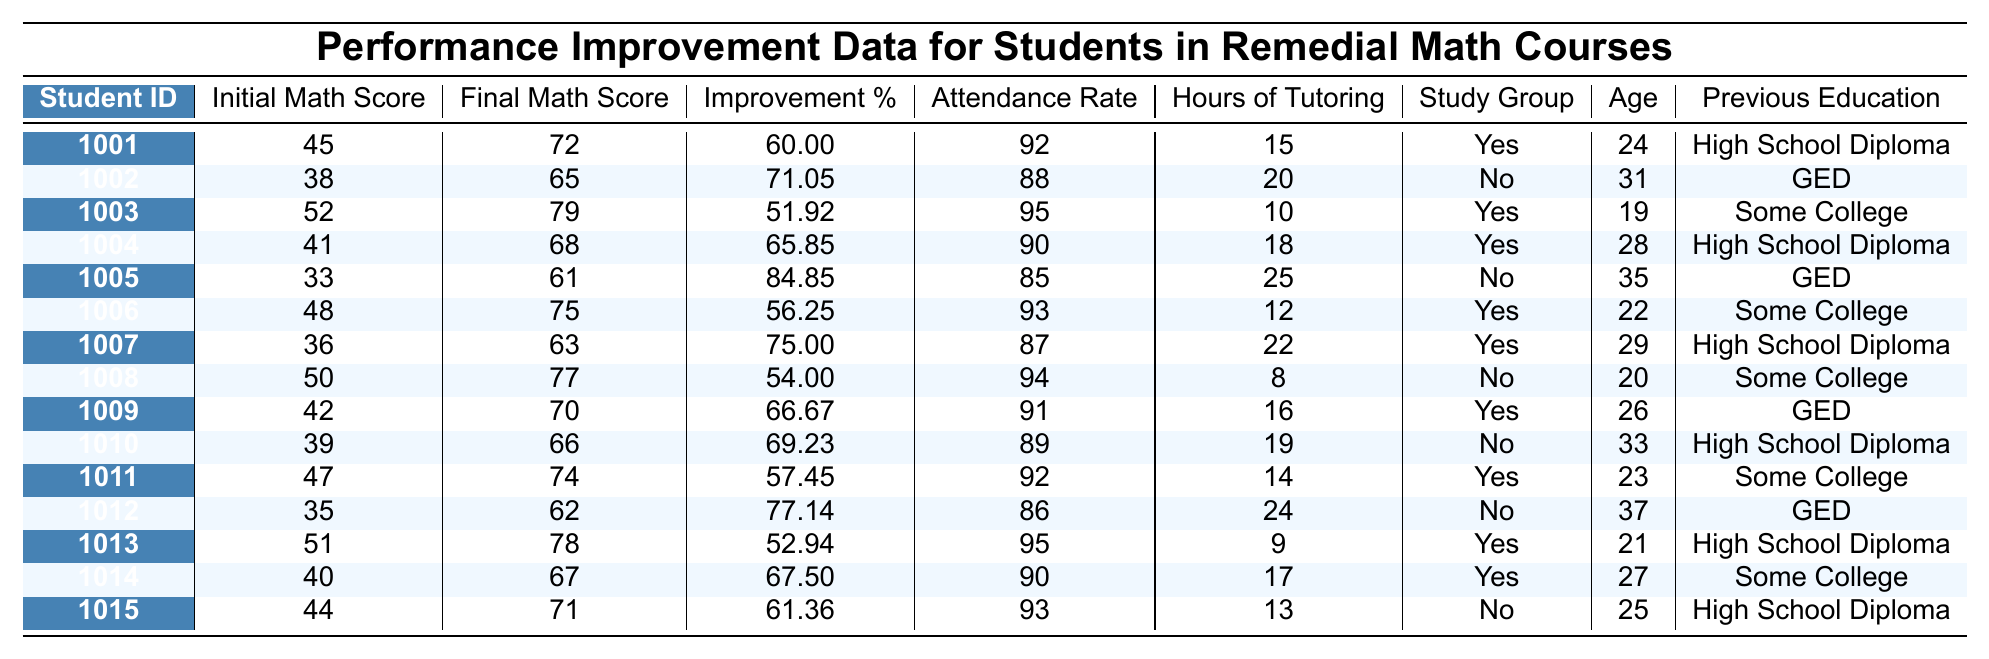What is the Improvement Percentage for Student ID 1001? The table indicates that the Improvement Percentage for Student ID 1001 is listed in the corresponding row, which shows a score of 60.00%.
Answer: 60.00% How many hours of tutoring did Student ID 1005 receive? The table shows that Student ID 1005 received 25 hours of tutoring, as found in the row for this student.
Answer: 25 What is the highest Final Math Score among the students? By reviewing the Final Math Score column, the highest score is 79, which corresponds to Student ID 1003.
Answer: 79 Is there a student with an Attendance Rate below 85? By checking the Attendance Rate column, we find students 1005 (85), 1008 (94), 1010 (89), and 1012 (86) who have rates above 85; however, Student ID 1007 has a rate of 87 which is below 85, indicating there are students with lower rates.
Answer: Yes What is the average Improvement Percentage for all students? To calculate this, we sum all the Improvement Percentages: 60.00 + 71.05 + 51.92 + 65.85 + 84.85 + 56.25 + 75.00 + 54.00 + 66.67 + 69.23 + 57.45 + 77.14 + 52.94 + 67.50 + 61.36 = 67.05, and then divide it by the total number of students (15) to get the average, resulting in approximately 67.05%.
Answer: 67.05% Are students who participated in study groups generally more likely to have higher Improvement Percentages? By comparing the Improvement Percentages of students with "Yes" in Study Group Participation to those with "No", we calculate the averages: the “Yes” students have an average of 64.86%, and “No” students have 69.23%. This indicates that the "No" students have slightly higher averages, although it is not definitive.
Answer: No What is the difference in Attendance Rates between the oldest (Student ID 1012) and youngest (Student ID 1003) students? The Attendance Rate for Student ID 1012 (age 37) is 86%, while for Student ID 1003 (age 19) it is 95%. The difference can be calculated as 95 - 86 = 9%.
Answer: 9% 